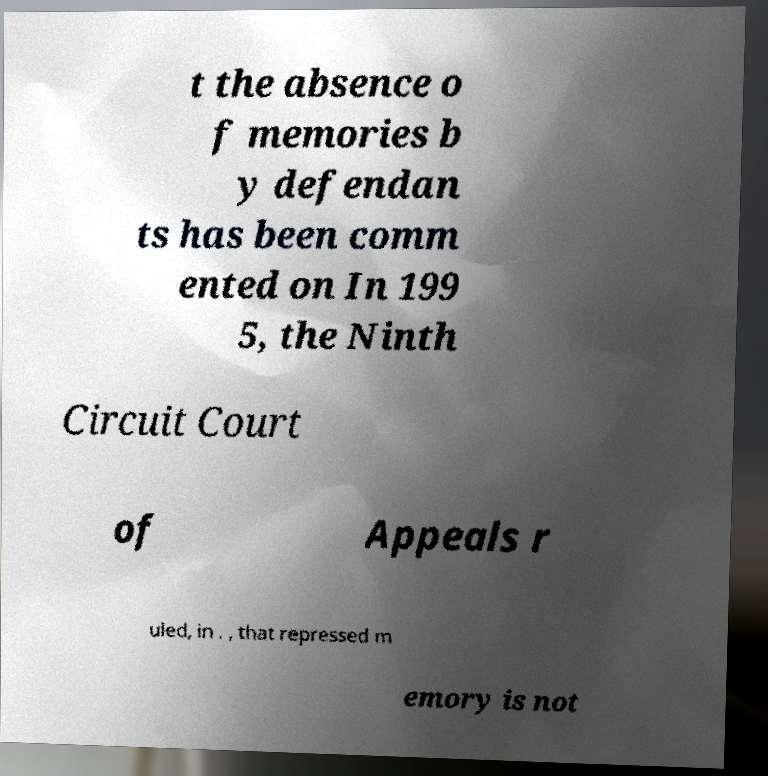What messages or text are displayed in this image? I need them in a readable, typed format. t the absence o f memories b y defendan ts has been comm ented on In 199 5, the Ninth Circuit Court of Appeals r uled, in . , that repressed m emory is not 